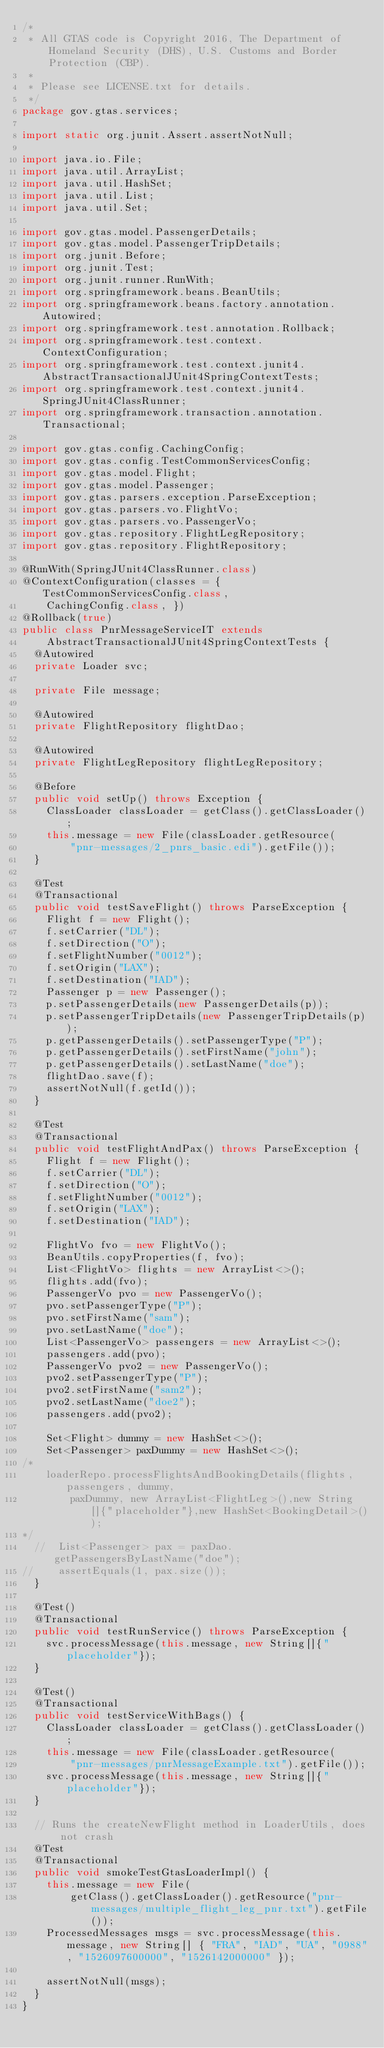<code> <loc_0><loc_0><loc_500><loc_500><_Java_>/*
 * All GTAS code is Copyright 2016, The Department of Homeland Security (DHS), U.S. Customs and Border Protection (CBP).
 * 
 * Please see LICENSE.txt for details.
 */
package gov.gtas.services;

import static org.junit.Assert.assertNotNull;

import java.io.File;
import java.util.ArrayList;
import java.util.HashSet;
import java.util.List;
import java.util.Set;

import gov.gtas.model.PassengerDetails;
import gov.gtas.model.PassengerTripDetails;
import org.junit.Before;
import org.junit.Test;
import org.junit.runner.RunWith;
import org.springframework.beans.BeanUtils;
import org.springframework.beans.factory.annotation.Autowired;
import org.springframework.test.annotation.Rollback;
import org.springframework.test.context.ContextConfiguration;
import org.springframework.test.context.junit4.AbstractTransactionalJUnit4SpringContextTests;
import org.springframework.test.context.junit4.SpringJUnit4ClassRunner;
import org.springframework.transaction.annotation.Transactional;

import gov.gtas.config.CachingConfig;
import gov.gtas.config.TestCommonServicesConfig;
import gov.gtas.model.Flight;
import gov.gtas.model.Passenger;
import gov.gtas.parsers.exception.ParseException;
import gov.gtas.parsers.vo.FlightVo;
import gov.gtas.parsers.vo.PassengerVo;
import gov.gtas.repository.FlightLegRepository;
import gov.gtas.repository.FlightRepository;

@RunWith(SpringJUnit4ClassRunner.class)
@ContextConfiguration(classes = { TestCommonServicesConfig.class,
		CachingConfig.class, })
@Rollback(true)
public class PnrMessageServiceIT extends
		AbstractTransactionalJUnit4SpringContextTests {
	@Autowired
	private Loader svc;

	private File message;

	@Autowired
	private FlightRepository flightDao;
	
	@Autowired
	private FlightLegRepository flightLegRepository;

	@Before
	public void setUp() throws Exception {
		ClassLoader classLoader = getClass().getClassLoader();
		this.message = new File(classLoader.getResource(
				"pnr-messages/2_pnrs_basic.edi").getFile());
	}

	@Test
	@Transactional
	public void testSaveFlight() throws ParseException {
		Flight f = new Flight();
		f.setCarrier("DL");
		f.setDirection("O");
		f.setFlightNumber("0012");
		f.setOrigin("LAX");
		f.setDestination("IAD");
		Passenger p = new Passenger();
		p.setPassengerDetails(new PassengerDetails(p));
		p.setPassengerTripDetails(new PassengerTripDetails(p));
		p.getPassengerDetails().setPassengerType("P");
		p.getPassengerDetails().setFirstName("john");
		p.getPassengerDetails().setLastName("doe");
		flightDao.save(f);
		assertNotNull(f.getId());
	}

	@Test
	@Transactional
	public void testFlightAndPax() throws ParseException {
		Flight f = new Flight();
		f.setCarrier("DL");
		f.setDirection("O");
		f.setFlightNumber("0012");
		f.setOrigin("LAX");
		f.setDestination("IAD");

		FlightVo fvo = new FlightVo();
		BeanUtils.copyProperties(f, fvo);
		List<FlightVo> flights = new ArrayList<>();
		flights.add(fvo);
		PassengerVo pvo = new PassengerVo();
		pvo.setPassengerType("P");
		pvo.setFirstName("sam");
		pvo.setLastName("doe");
		List<PassengerVo> passengers = new ArrayList<>();
		passengers.add(pvo);
		PassengerVo pvo2 = new PassengerVo();
		pvo2.setPassengerType("P");
		pvo2.setFirstName("sam2");
		pvo2.setLastName("doe2");
		passengers.add(pvo2);

		Set<Flight> dummy = new HashSet<>();
		Set<Passenger> paxDummy = new HashSet<>();
/*
		loaderRepo.processFlightsAndBookingDetails(flights, passengers, dummy,
				paxDummy, new ArrayList<FlightLeg>(),new String[]{"placeholder"},new HashSet<BookingDetail>());
*/
	//	List<Passenger> pax = paxDao.getPassengersByLastName("doe");
//		assertEquals(1, pax.size());
	}

	@Test()
	@Transactional
	public void testRunService() throws ParseException {
    svc.processMessage(this.message, new String[]{"placeholder"});
	}

	@Test()
	@Transactional
	public void testServiceWithBags() {
		ClassLoader classLoader = getClass().getClassLoader();
		this.message = new File(classLoader.getResource(
				"pnr-messages/pnrMessageExample.txt").getFile());
		svc.processMessage(this.message, new String[]{"placeholder"});
	}

  // Runs the createNewFlight method in LoaderUtils, does not crash
	@Test
	@Transactional
	public void smokeTestGtasLoaderImpl() {
		this.message = new File(
				getClass().getClassLoader().getResource("pnr-messages/multiple_flight_leg_pnr.txt").getFile());
    ProcessedMessages msgs = svc.processMessage(this.message, new String[] { "FRA", "IAD", "UA", "0988", "1526097600000", "1526142000000" });

    assertNotNull(msgs);
	}
}
</code> 